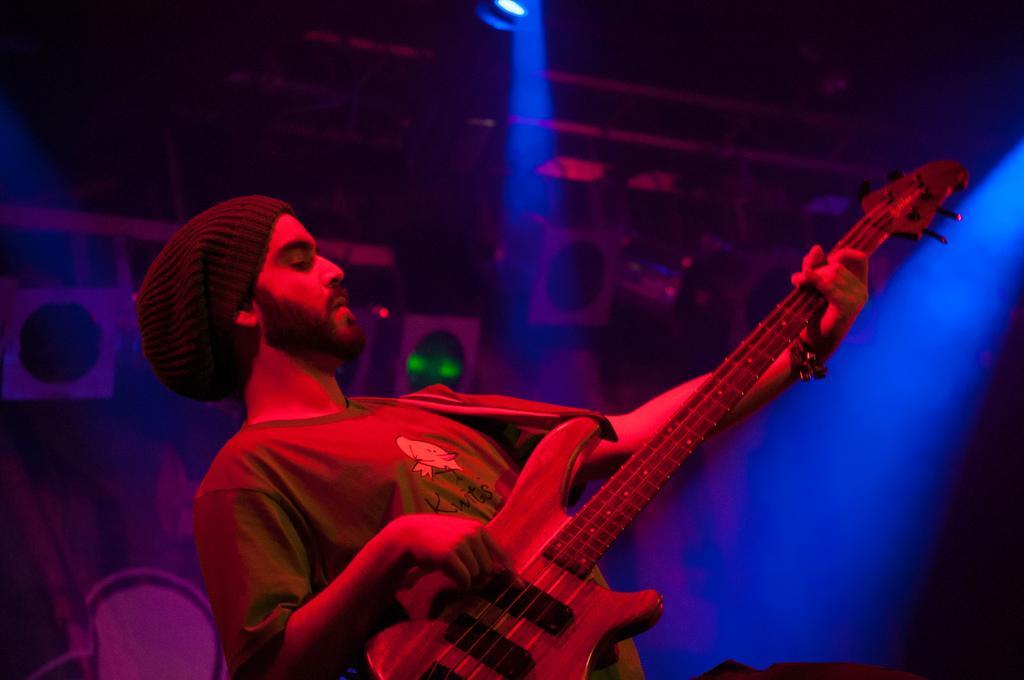Could you give a brief overview of what you see in this image? In this image and in this room one person is playing the guitar and background is very dark. 